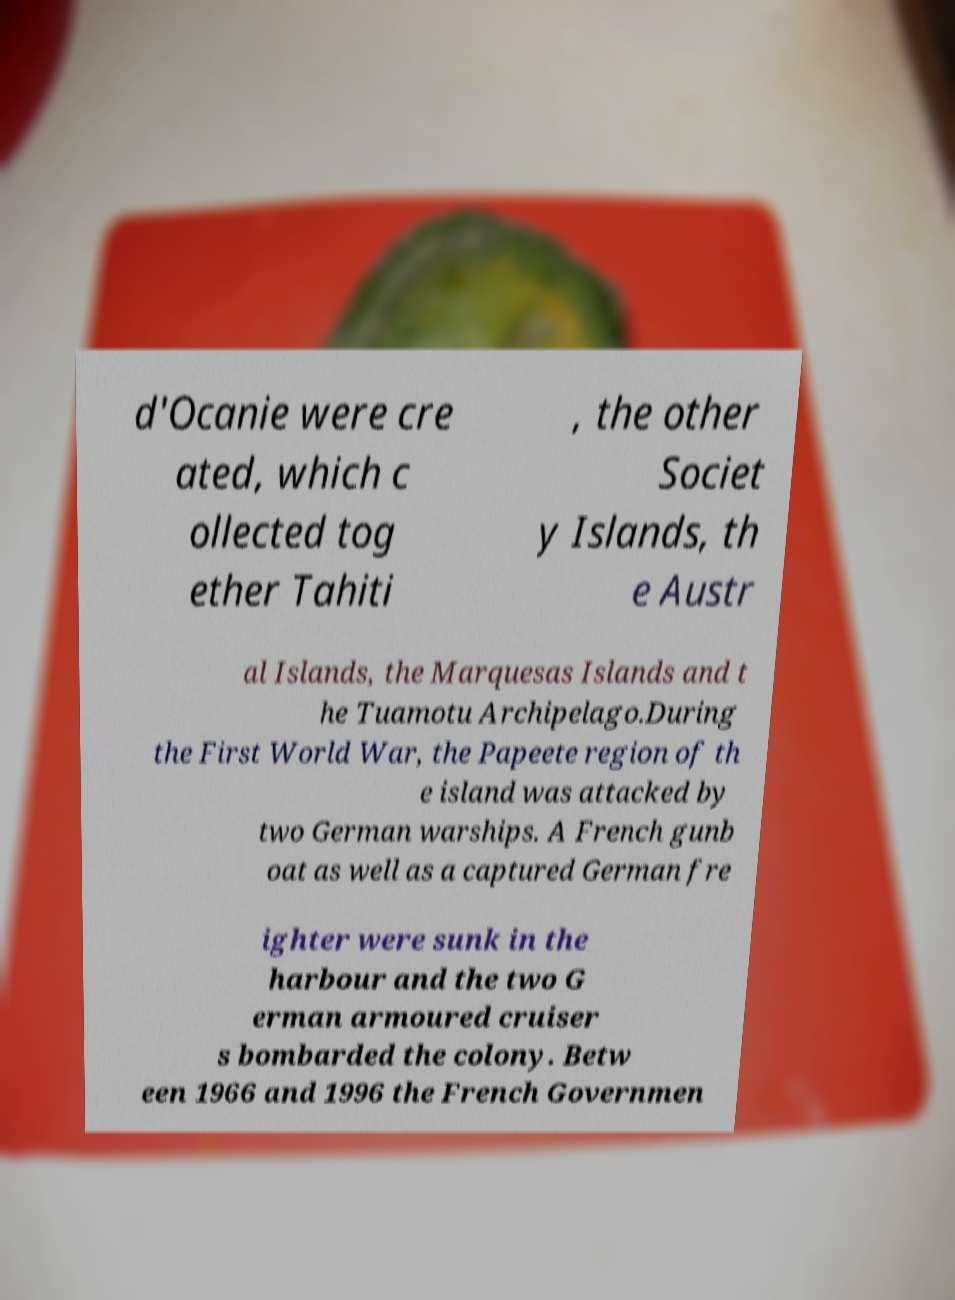What messages or text are displayed in this image? I need them in a readable, typed format. d'Ocanie were cre ated, which c ollected tog ether Tahiti , the other Societ y Islands, th e Austr al Islands, the Marquesas Islands and t he Tuamotu Archipelago.During the First World War, the Papeete region of th e island was attacked by two German warships. A French gunb oat as well as a captured German fre ighter were sunk in the harbour and the two G erman armoured cruiser s bombarded the colony. Betw een 1966 and 1996 the French Governmen 